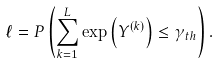Convert formula to latex. <formula><loc_0><loc_0><loc_500><loc_500>\ell = P \left ( \sum _ { k = 1 } ^ { L } { \exp \left ( Y ^ { ( k ) } \right ) } \leq \gamma _ { t h } \right ) .</formula> 